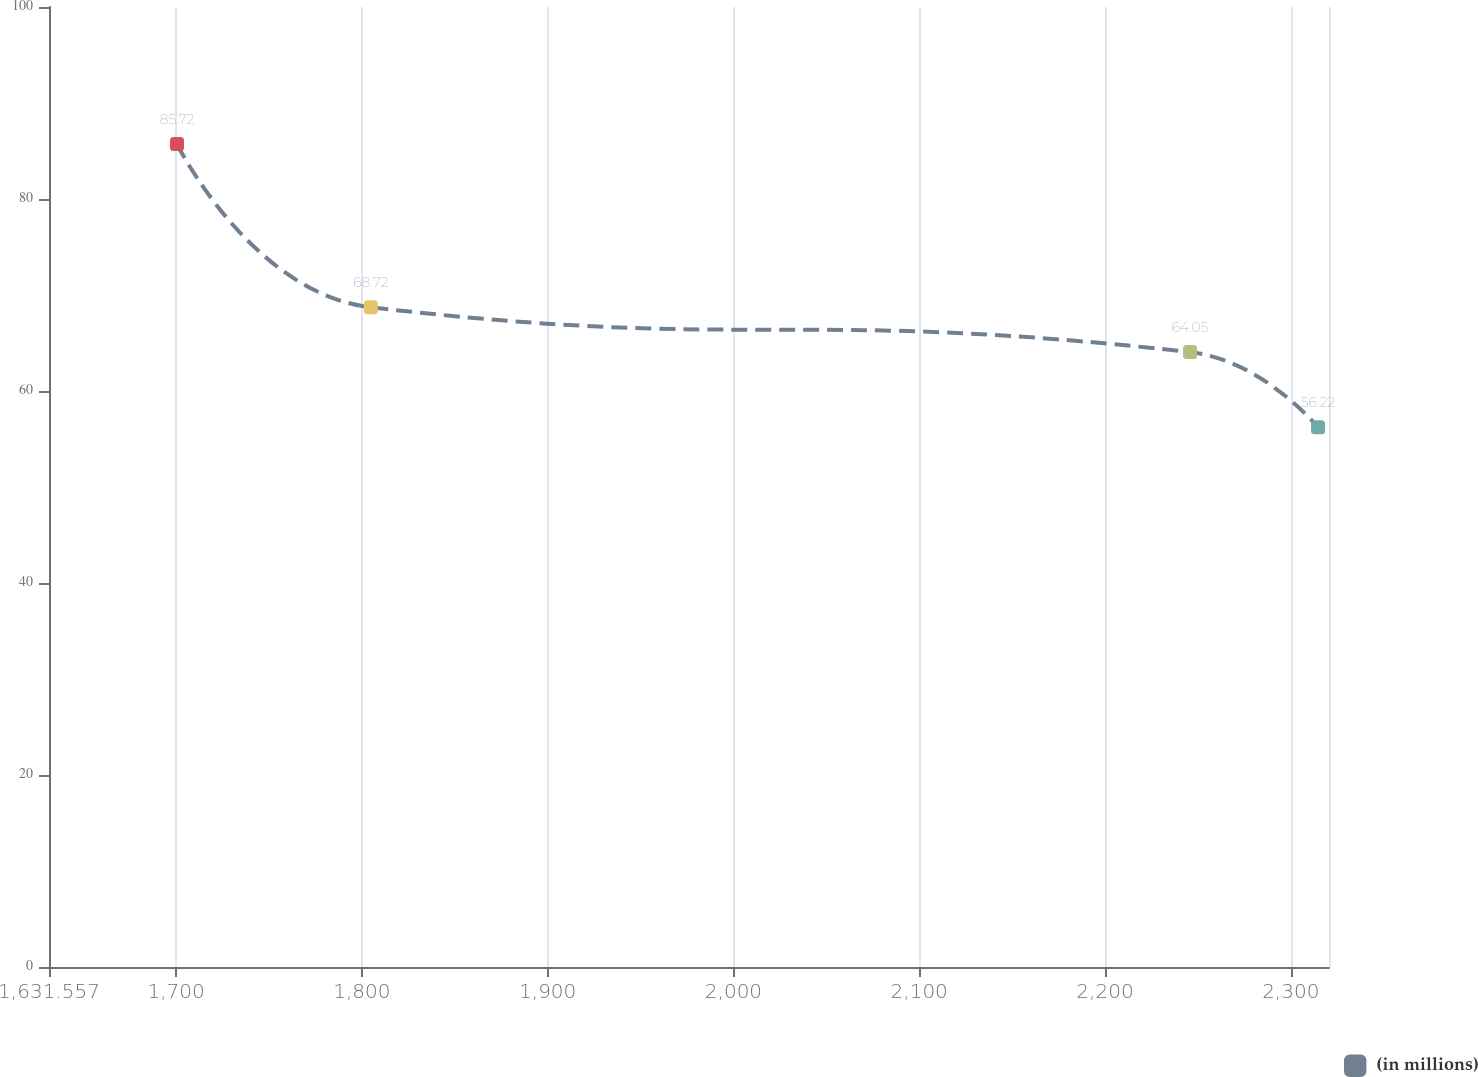Convert chart to OTSL. <chart><loc_0><loc_0><loc_500><loc_500><line_chart><ecel><fcel>(in millions)<nl><fcel>1700.46<fcel>85.72<nl><fcel>1804.82<fcel>68.72<nl><fcel>2245.8<fcel>64.05<nl><fcel>2314.7<fcel>56.22<nl><fcel>2389.49<fcel>52.94<nl></chart> 